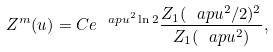<formula> <loc_0><loc_0><loc_500><loc_500>Z ^ { m } ( u ) = C e ^ { \ a p u ^ { 2 } \ln 2 } \frac { Z _ { 1 } ( \ a p u ^ { 2 } / 2 ) ^ { 2 } } { Z _ { 1 } ( \ a p u ^ { 2 } ) } ,</formula> 